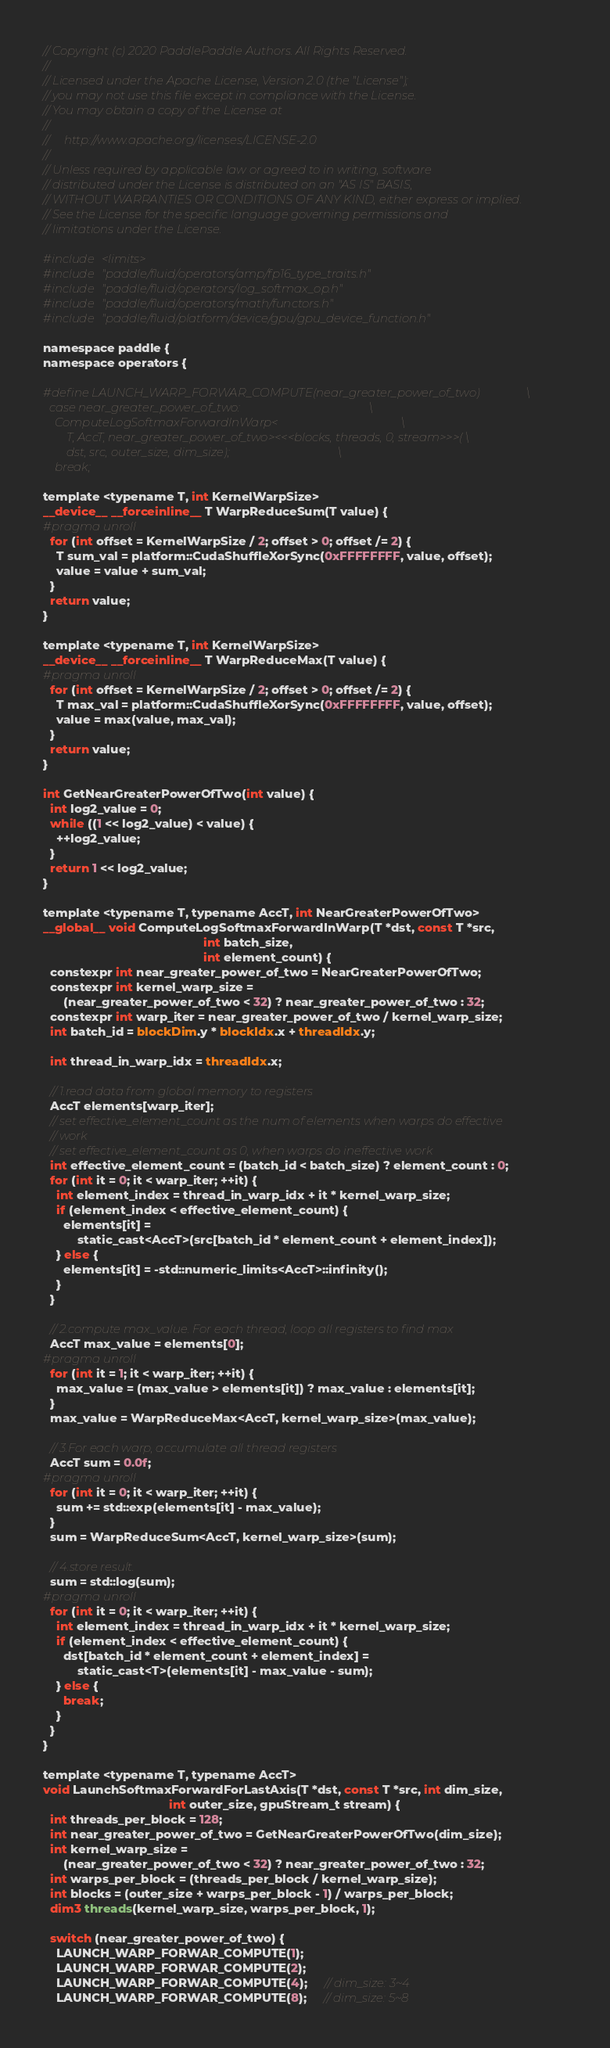<code> <loc_0><loc_0><loc_500><loc_500><_Cuda_>// Copyright (c) 2020 PaddlePaddle Authors. All Rights Reserved.
//
// Licensed under the Apache License, Version 2.0 (the "License");
// you may not use this file except in compliance with the License.
// You may obtain a copy of the License at
//
//     http://www.apache.org/licenses/LICENSE-2.0
//
// Unless required by applicable law or agreed to in writing, software
// distributed under the License is distributed on an "AS IS" BASIS,
// WITHOUT WARRANTIES OR CONDITIONS OF ANY KIND, either express or implied.
// See the License for the specific language governing permissions and
// limitations under the License.

#include <limits>
#include "paddle/fluid/operators/amp/fp16_type_traits.h"
#include "paddle/fluid/operators/log_softmax_op.h"
#include "paddle/fluid/operators/math/functors.h"
#include "paddle/fluid/platform/device/gpu/gpu_device_function.h"

namespace paddle {
namespace operators {

#define LAUNCH_WARP_FORWAR_COMPUTE(near_greater_power_of_two)                \
  case near_greater_power_of_two:                                            \
    ComputeLogSoftmaxForwardInWarp<                                          \
        T, AccT, near_greater_power_of_two><<<blocks, threads, 0, stream>>>( \
        dst, src, outer_size, dim_size);                                     \
    break;

template <typename T, int KernelWarpSize>
__device__ __forceinline__ T WarpReduceSum(T value) {
#pragma unroll
  for (int offset = KernelWarpSize / 2; offset > 0; offset /= 2) {
    T sum_val = platform::CudaShuffleXorSync(0xFFFFFFFF, value, offset);
    value = value + sum_val;
  }
  return value;
}

template <typename T, int KernelWarpSize>
__device__ __forceinline__ T WarpReduceMax(T value) {
#pragma unroll
  for (int offset = KernelWarpSize / 2; offset > 0; offset /= 2) {
    T max_val = platform::CudaShuffleXorSync(0xFFFFFFFF, value, offset);
    value = max(value, max_val);
  }
  return value;
}

int GetNearGreaterPowerOfTwo(int value) {
  int log2_value = 0;
  while ((1 << log2_value) < value) {
    ++log2_value;
  }
  return 1 << log2_value;
}

template <typename T, typename AccT, int NearGreaterPowerOfTwo>
__global__ void ComputeLogSoftmaxForwardInWarp(T *dst, const T *src,
                                               int batch_size,
                                               int element_count) {
  constexpr int near_greater_power_of_two = NearGreaterPowerOfTwo;
  constexpr int kernel_warp_size =
      (near_greater_power_of_two < 32) ? near_greater_power_of_two : 32;
  constexpr int warp_iter = near_greater_power_of_two / kernel_warp_size;
  int batch_id = blockDim.y * blockIdx.x + threadIdx.y;

  int thread_in_warp_idx = threadIdx.x;

  // 1.read data from global memory to registers
  AccT elements[warp_iter];
  // set effective_element_count as the num of elements when warps do effective
  // work
  // set effective_element_count as 0, when warps do ineffective work
  int effective_element_count = (batch_id < batch_size) ? element_count : 0;
  for (int it = 0; it < warp_iter; ++it) {
    int element_index = thread_in_warp_idx + it * kernel_warp_size;
    if (element_index < effective_element_count) {
      elements[it] =
          static_cast<AccT>(src[batch_id * element_count + element_index]);
    } else {
      elements[it] = -std::numeric_limits<AccT>::infinity();
    }
  }

  // 2.compute max_value. For each thread, loop all registers to find max
  AccT max_value = elements[0];
#pragma unroll
  for (int it = 1; it < warp_iter; ++it) {
    max_value = (max_value > elements[it]) ? max_value : elements[it];
  }
  max_value = WarpReduceMax<AccT, kernel_warp_size>(max_value);

  // 3.For each warp, accumulate all thread registers
  AccT sum = 0.0f;
#pragma unroll
  for (int it = 0; it < warp_iter; ++it) {
    sum += std::exp(elements[it] - max_value);
  }
  sum = WarpReduceSum<AccT, kernel_warp_size>(sum);

  // 4.store result.
  sum = std::log(sum);
#pragma unroll
  for (int it = 0; it < warp_iter; ++it) {
    int element_index = thread_in_warp_idx + it * kernel_warp_size;
    if (element_index < effective_element_count) {
      dst[batch_id * element_count + element_index] =
          static_cast<T>(elements[it] - max_value - sum);
    } else {
      break;
    }
  }
}

template <typename T, typename AccT>
void LaunchSoftmaxForwardForLastAxis(T *dst, const T *src, int dim_size,
                                     int outer_size, gpuStream_t stream) {
  int threads_per_block = 128;
  int near_greater_power_of_two = GetNearGreaterPowerOfTwo(dim_size);
  int kernel_warp_size =
      (near_greater_power_of_two < 32) ? near_greater_power_of_two : 32;
  int warps_per_block = (threads_per_block / kernel_warp_size);
  int blocks = (outer_size + warps_per_block - 1) / warps_per_block;
  dim3 threads(kernel_warp_size, warps_per_block, 1);

  switch (near_greater_power_of_two) {
    LAUNCH_WARP_FORWAR_COMPUTE(1);
    LAUNCH_WARP_FORWAR_COMPUTE(2);
    LAUNCH_WARP_FORWAR_COMPUTE(4);     // dim_size: 3~4
    LAUNCH_WARP_FORWAR_COMPUTE(8);     // dim_size: 5~8</code> 